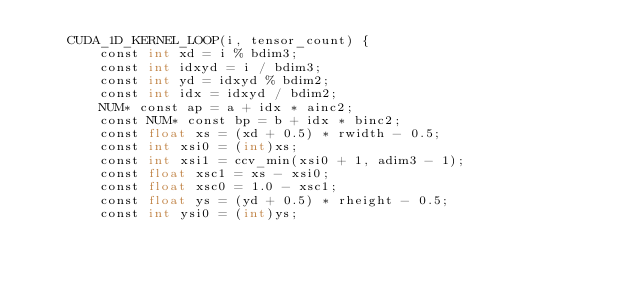Convert code to text. <code><loc_0><loc_0><loc_500><loc_500><_Cuda_>	CUDA_1D_KERNEL_LOOP(i, tensor_count) {
		const int xd = i % bdim3;
		const int idxyd = i / bdim3;
		const int yd = idxyd % bdim2;
		const int idx = idxyd / bdim2;
		NUM* const ap = a + idx * ainc2;
		const NUM* const bp = b + idx * binc2;
		const float xs = (xd + 0.5) * rwidth - 0.5;
		const int xsi0 = (int)xs;
		const int xsi1 = ccv_min(xsi0 + 1, adim3 - 1);
		const float xsc1 = xs - xsi0;
		const float xsc0 = 1.0 - xsc1;
		const float ys = (yd + 0.5) * rheight - 0.5;
		const int ysi0 = (int)ys;</code> 